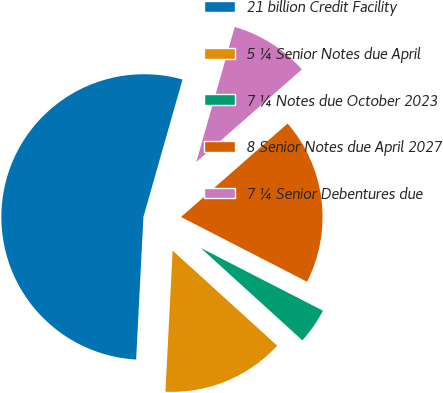<chart> <loc_0><loc_0><loc_500><loc_500><pie_chart><fcel>21 billion Credit Facility<fcel>5 ¼ Senior Notes due April<fcel>7 ¼ Notes due October 2023<fcel>8 Senior Notes due April 2027<fcel>7 ¼ Senior Debentures due<nl><fcel>53.6%<fcel>14.07%<fcel>4.19%<fcel>19.01%<fcel>9.13%<nl></chart> 